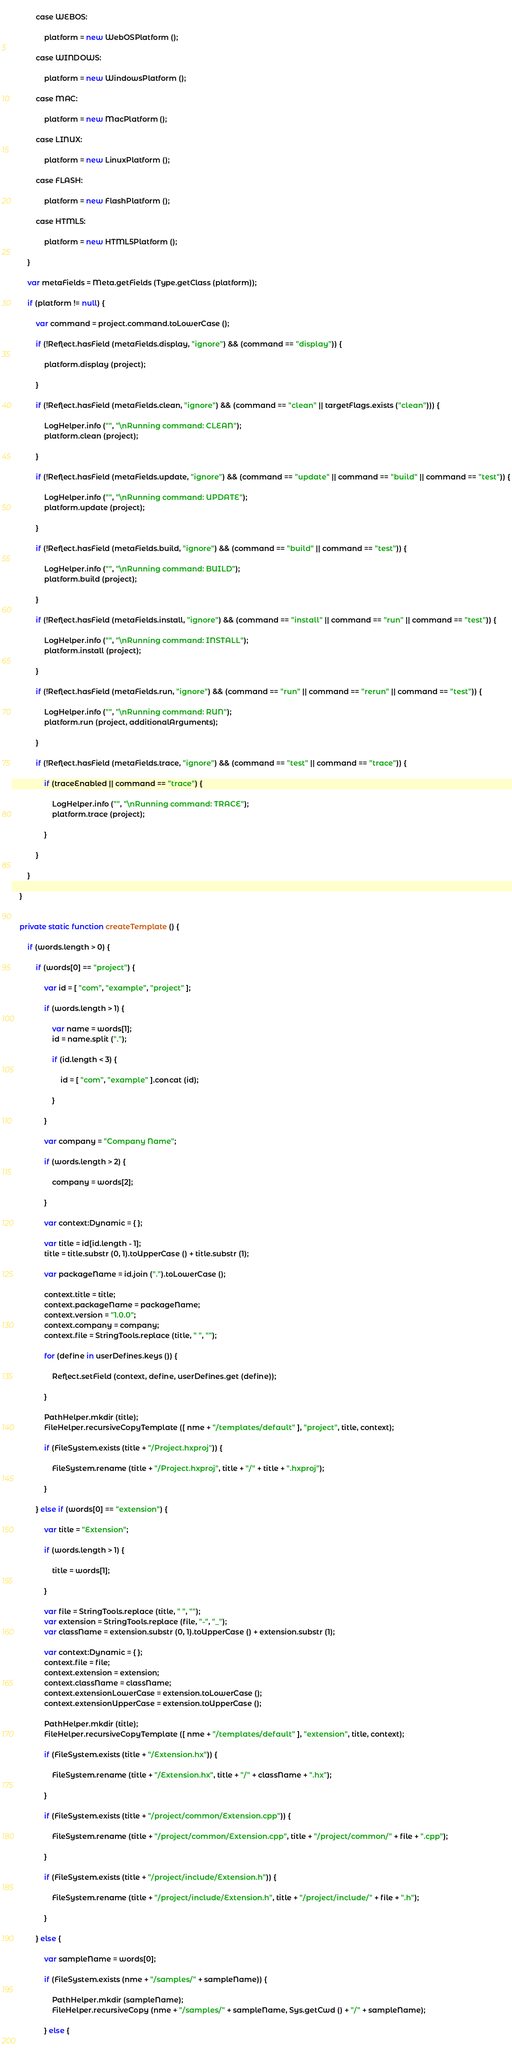<code> <loc_0><loc_0><loc_500><loc_500><_Haxe_>			
			case WEBOS:
				
				platform = new WebOSPlatform ();
			
			case WINDOWS:
				
				platform = new WindowsPlatform ();
			
			case MAC:
				
				platform = new MacPlatform ();
				
			case LINUX:
				
				platform = new LinuxPlatform ();
				
			case FLASH:
				
				platform = new FlashPlatform ();
				
			case HTML5:
				
				platform = new HTML5Platform ();
			
		}
		
		var metaFields = Meta.getFields (Type.getClass (platform));
		
		if (platform != null) {
			
			var command = project.command.toLowerCase ();
			
			if (!Reflect.hasField (metaFields.display, "ignore") && (command == "display")) {
				
				platform.display (project);
				
			}
			
			if (!Reflect.hasField (metaFields.clean, "ignore") && (command == "clean" || targetFlags.exists ("clean"))) {
				
				LogHelper.info ("", "\nRunning command: CLEAN");
				platform.clean (project);
				
			}
			
			if (!Reflect.hasField (metaFields.update, "ignore") && (command == "update" || command == "build" || command == "test")) {
				
				LogHelper.info ("", "\nRunning command: UPDATE");
				platform.update (project);
				
			}
			
			if (!Reflect.hasField (metaFields.build, "ignore") && (command == "build" || command == "test")) {
				
				LogHelper.info ("", "\nRunning command: BUILD");
				platform.build (project);
				
			}
			
			if (!Reflect.hasField (metaFields.install, "ignore") && (command == "install" || command == "run" || command == "test")) {
				
				LogHelper.info ("", "\nRunning command: INSTALL");
				platform.install (project);
				
			}
		
			if (!Reflect.hasField (metaFields.run, "ignore") && (command == "run" || command == "rerun" || command == "test")) {
				
				LogHelper.info ("", "\nRunning command: RUN");
				platform.run (project, additionalArguments);
				
			}
		
			if (!Reflect.hasField (metaFields.trace, "ignore") && (command == "test" || command == "trace")) {
				
				if (traceEnabled || command == "trace") {
					
					LogHelper.info ("", "\nRunning command: TRACE");
					platform.trace (project);
					
				}
				
			}
			
		}
		
	}
	
	
	private static function createTemplate () {
		
		if (words.length > 0) {
			
			if (words[0] == "project") {
				
				var id = [ "com", "example", "project" ];
				
				if (words.length > 1) {
					
					var name = words[1];
					id = name.split (".");
					
					if (id.length < 3) {
						
						id = [ "com", "example" ].concat (id);
						
					}
					
				}
				
				var company = "Company Name";
				
				if (words.length > 2) {
					
					company = words[2];
					
				}
				
				var context:Dynamic = { };
				
				var title = id[id.length - 1];
				title = title.substr (0, 1).toUpperCase () + title.substr (1);
				
				var packageName = id.join (".").toLowerCase ();
				
				context.title = title;
				context.packageName = packageName;
				context.version = "1.0.0";
				context.company = company;
				context.file = StringTools.replace (title, " ", "");
				
				for (define in userDefines.keys ()) {
					
					Reflect.setField (context, define, userDefines.get (define));
					
				}
				
				PathHelper.mkdir (title);
				FileHelper.recursiveCopyTemplate ([ nme + "/templates/default" ], "project", title, context);
				
				if (FileSystem.exists (title + "/Project.hxproj")) {
					
					FileSystem.rename (title + "/Project.hxproj", title + "/" + title + ".hxproj");
					
				}
				
			} else if (words[0] == "extension") {
				
				var title = "Extension";
				
				if (words.length > 1) {
					
					title = words[1];
					
				}
				
				var file = StringTools.replace (title, " ", "");
				var extension = StringTools.replace (file, "-", "_");
				var className = extension.substr (0, 1).toUpperCase () + extension.substr (1);
				
				var context:Dynamic = { };
				context.file = file;
				context.extension = extension;
				context.className = className;
				context.extensionLowerCase = extension.toLowerCase ();
				context.extensionUpperCase = extension.toUpperCase ();
				
				PathHelper.mkdir (title);
				FileHelper.recursiveCopyTemplate ([ nme + "/templates/default" ], "extension", title, context);
				
				if (FileSystem.exists (title + "/Extension.hx")) {
					
					FileSystem.rename (title + "/Extension.hx", title + "/" + className + ".hx");
					
				}
				
				if (FileSystem.exists (title + "/project/common/Extension.cpp")) {
					
					FileSystem.rename (title + "/project/common/Extension.cpp", title + "/project/common/" + file + ".cpp");
					
				}
				
				if (FileSystem.exists (title + "/project/include/Extension.h")) {
					
					FileSystem.rename (title + "/project/include/Extension.h", title + "/project/include/" + file + ".h");
					
				}
				
			} else {
				
				var sampleName = words[0];
				
				if (FileSystem.exists (nme + "/samples/" + sampleName)) {
					
					PathHelper.mkdir (sampleName);
					FileHelper.recursiveCopy (nme + "/samples/" + sampleName, Sys.getCwd () + "/" + sampleName);
					
				} else {
					</code> 